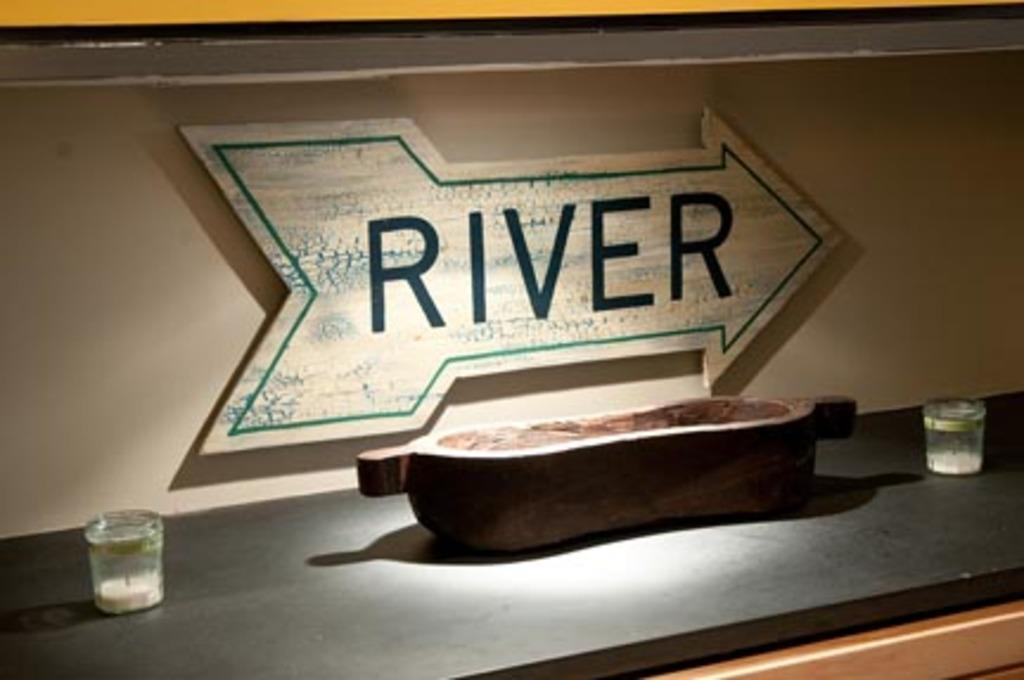<image>
Provide a brief description of the given image. A sign indicates which direction the river is. 